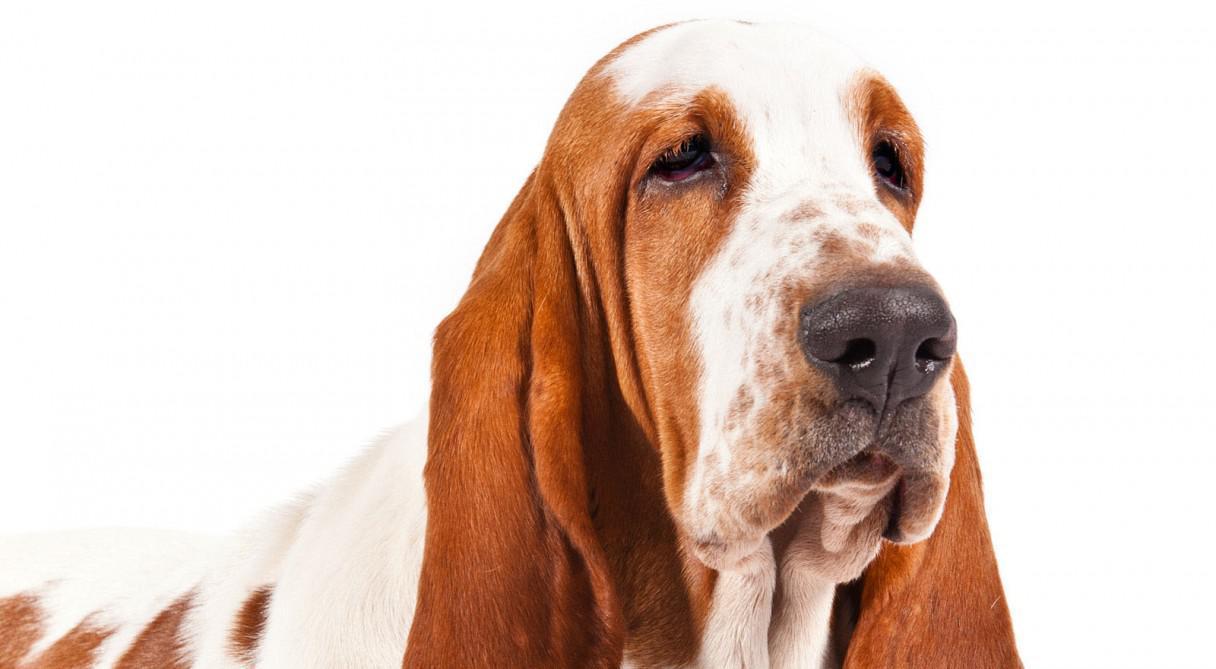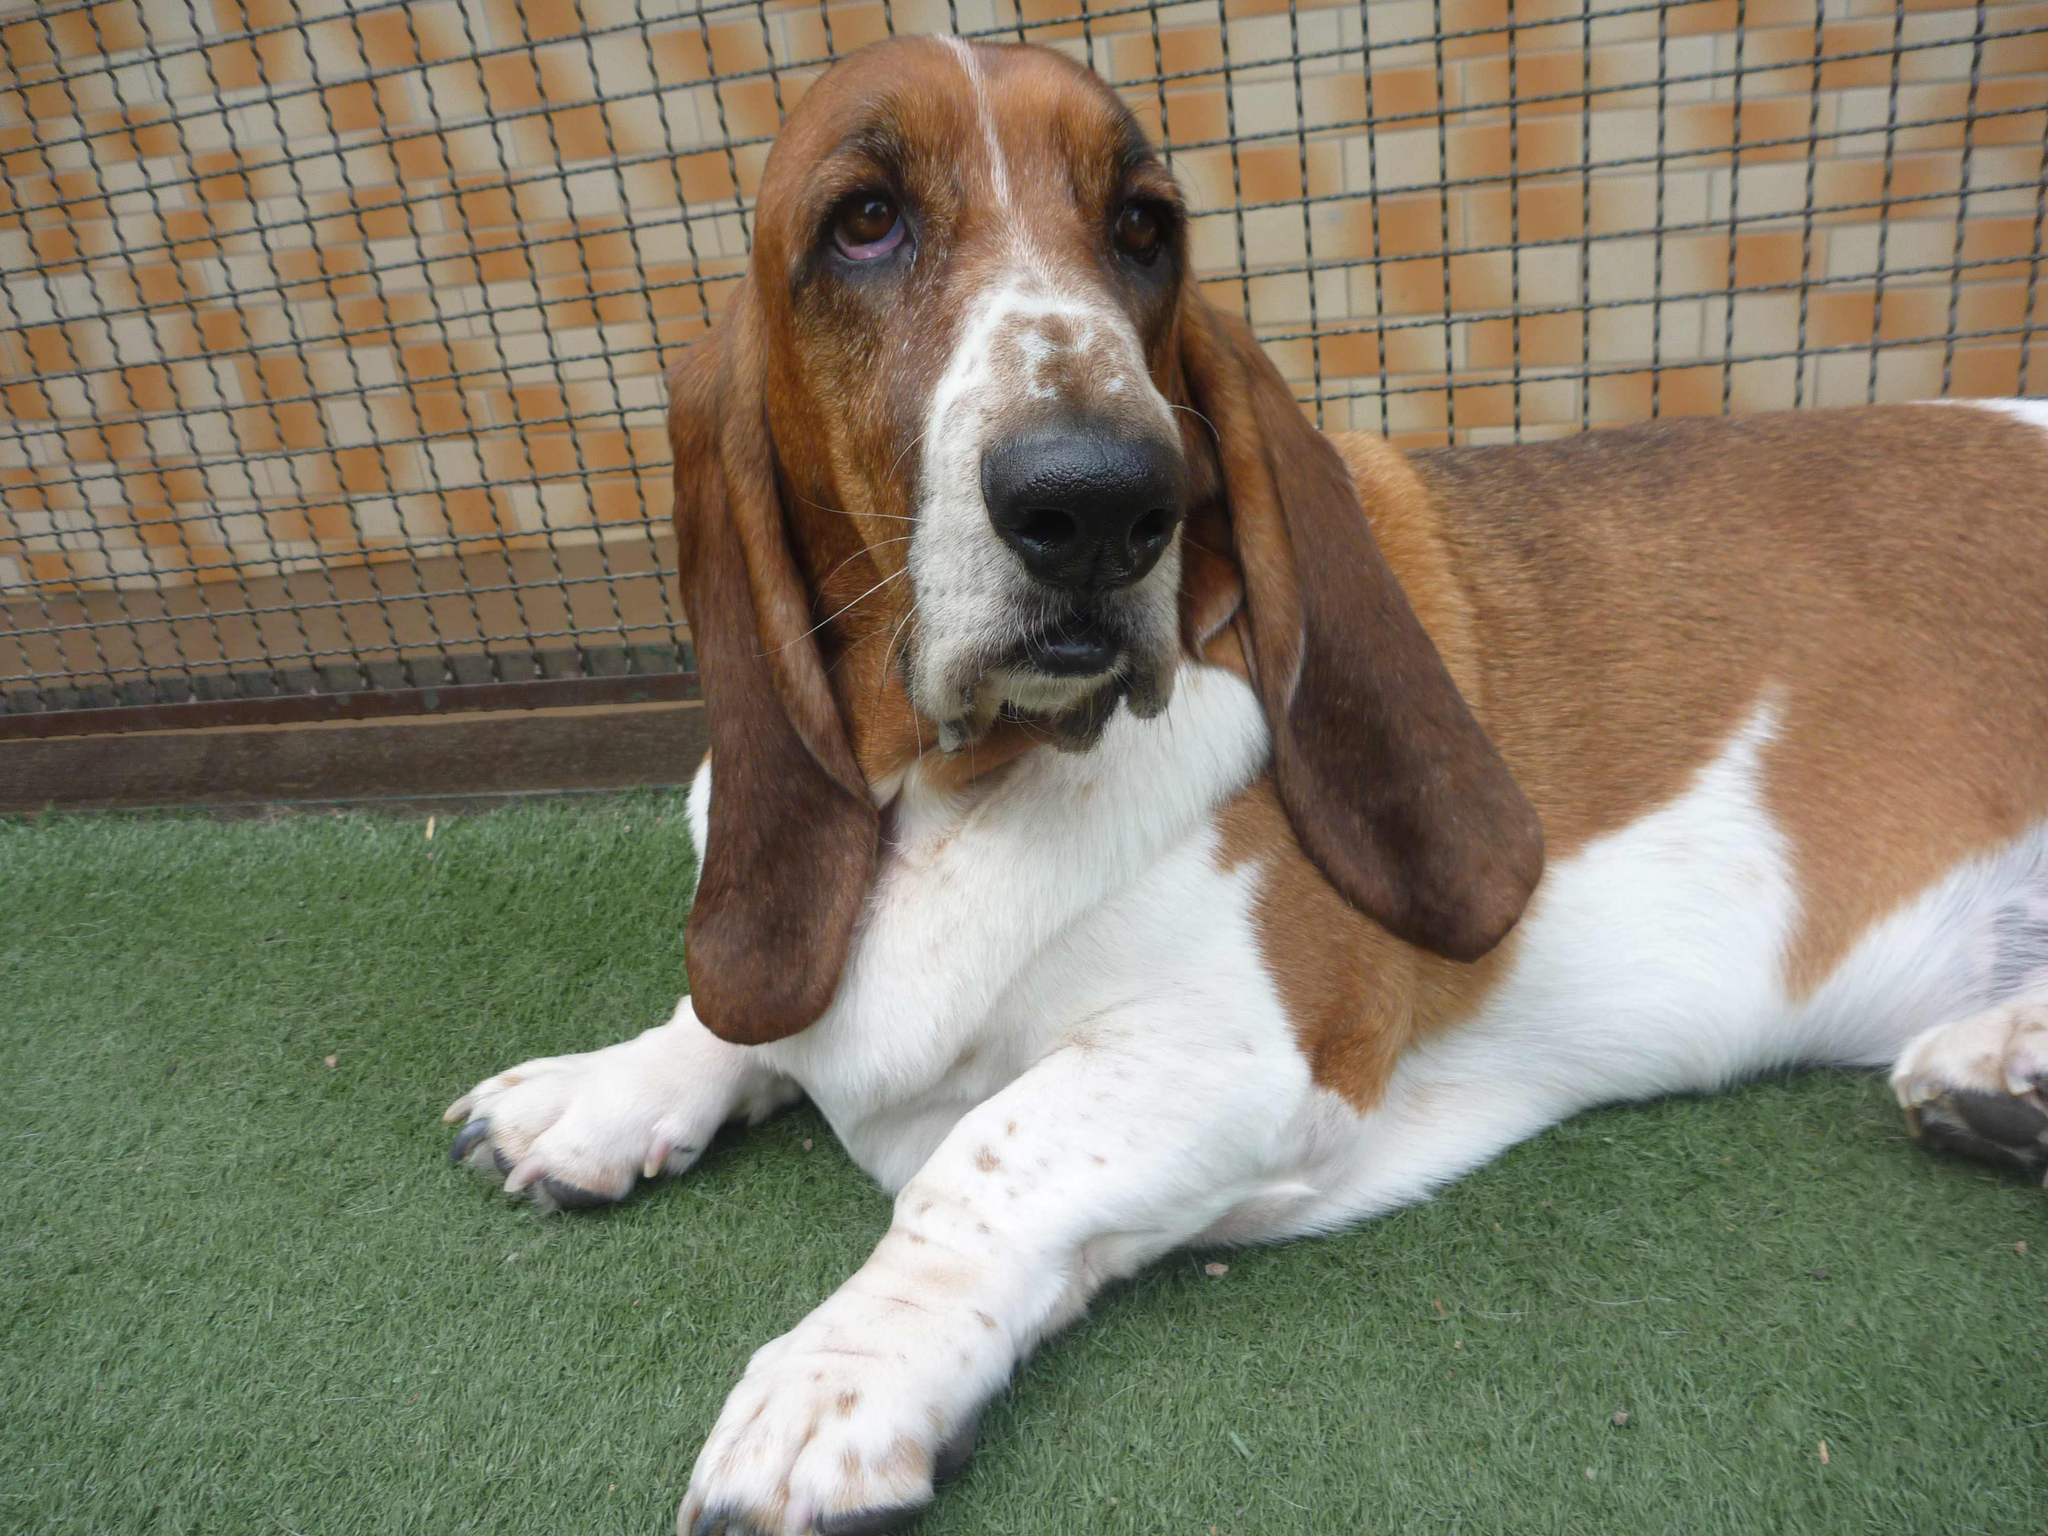The first image is the image on the left, the second image is the image on the right. For the images shown, is this caption "The dog in the image on the right is standing on the grass." true? Answer yes or no. No. The first image is the image on the left, the second image is the image on the right. Examine the images to the left and right. Is the description "One image shows a basset hound standing on all fours in profile, and the other image shows a basset hound viewed head on." accurate? Answer yes or no. No. 